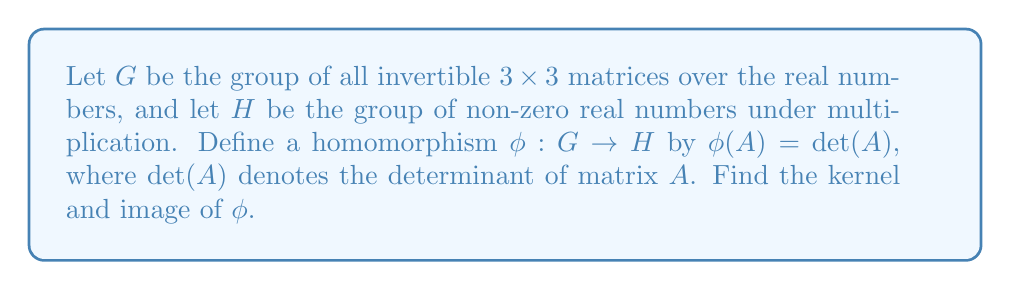What is the answer to this math problem? To solve this problem, we need to understand the concepts of kernel and image of a group homomorphism, as well as the properties of determinants.

1. Kernel:
The kernel of a homomorphism $\phi : G \to H$ is defined as:
$$\text{ker}(\phi) = \{g \in G : \phi(g) = e_H\}$$
where $e_H$ is the identity element of $H$.

In this case, we need to find all matrices $A \in G$ such that $\phi(A) = \det(A) = 1$, since 1 is the identity element in $H$ (the group of non-zero real numbers under multiplication).

The set of all $3 \times 3$ matrices with determinant 1 is known as the special linear group $SL(3, \mathbb{R})$. Therefore,
$$\text{ker}(\phi) = SL(3, \mathbb{R})$$

2. Image:
The image of a homomorphism $\phi : G \to H$ is defined as:
$$\text{Im}(\phi) = \{\phi(g) : g \in G\}$$

To find the image, we need to determine what values the determinant of a $3 \times 3$ invertible matrix can take.

Since the determinant is a continuous function and $G$ consists of all invertible matrices, the determinant can take any non-zero real value. Therefore,
$$\text{Im}(\phi) = H = \mathbb{R} \setminus \{0\}$$

This result is particularly relevant to our persona, as it demonstrates the power and elegance of abstract algebra in analyzing mathematical structures, much like how Imdaad Hamid has applied mathematical concepts in his work on cryptography and coding theory.
Answer: Kernel: $\text{ker}(\phi) = SL(3, \mathbb{R})$ (the special linear group of $3 \times 3$ matrices with determinant 1)
Image: $\text{Im}(\phi) = \mathbb{R} \setminus \{0\}$ (all non-zero real numbers) 